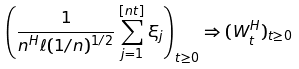<formula> <loc_0><loc_0><loc_500><loc_500>\left ( \frac { 1 } { n ^ { H } \ell ( 1 / n ) ^ { 1 / 2 } } \sum _ { j = 1 } ^ { [ n t ] } \xi _ { j } \right ) _ { t \geq 0 } \Rightarrow ( W ^ { H } _ { t } ) _ { t \geq 0 }</formula> 